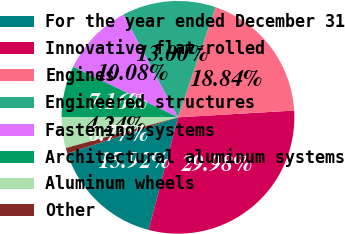Convert chart. <chart><loc_0><loc_0><loc_500><loc_500><pie_chart><fcel>For the year ended December 31<fcel>Innovative flat-rolled<fcel>Engines<fcel>Engineered structures<fcel>Fastening systems<fcel>Architectural aluminum systems<fcel>Aluminum wheels<fcel>Other<nl><fcel>15.92%<fcel>29.97%<fcel>18.84%<fcel>13.0%<fcel>10.08%<fcel>7.16%<fcel>4.24%<fcel>0.77%<nl></chart> 